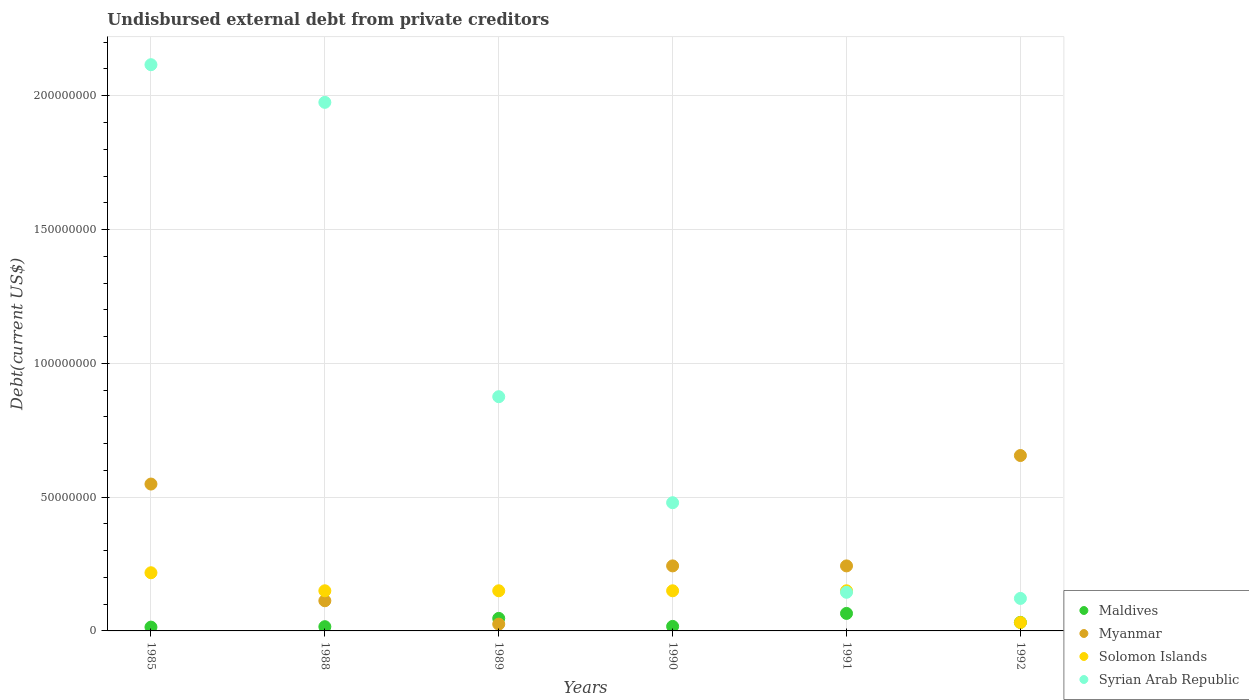How many different coloured dotlines are there?
Your answer should be very brief. 4. What is the total debt in Myanmar in 1990?
Provide a succinct answer. 2.43e+07. Across all years, what is the maximum total debt in Maldives?
Keep it short and to the point. 6.54e+06. Across all years, what is the minimum total debt in Syrian Arab Republic?
Keep it short and to the point. 1.21e+07. What is the total total debt in Syrian Arab Republic in the graph?
Make the answer very short. 5.71e+08. What is the difference between the total debt in Myanmar in 1985 and that in 1991?
Ensure brevity in your answer.  3.06e+07. What is the difference between the total debt in Myanmar in 1985 and the total debt in Syrian Arab Republic in 1988?
Keep it short and to the point. -1.43e+08. What is the average total debt in Syrian Arab Republic per year?
Provide a short and direct response. 9.52e+07. In the year 1988, what is the difference between the total debt in Maldives and total debt in Solomon Islands?
Offer a very short reply. -1.34e+07. What is the ratio of the total debt in Syrian Arab Republic in 1988 to that in 1990?
Your answer should be very brief. 4.12. Is the total debt in Myanmar in 1989 less than that in 1990?
Your answer should be very brief. Yes. Is the difference between the total debt in Maldives in 1988 and 1991 greater than the difference between the total debt in Solomon Islands in 1988 and 1991?
Make the answer very short. No. What is the difference between the highest and the second highest total debt in Myanmar?
Offer a very short reply. 1.07e+07. What is the difference between the highest and the lowest total debt in Myanmar?
Your response must be concise. 6.30e+07. Is the sum of the total debt in Syrian Arab Republic in 1985 and 1991 greater than the maximum total debt in Solomon Islands across all years?
Keep it short and to the point. Yes. Is it the case that in every year, the sum of the total debt in Myanmar and total debt in Maldives  is greater than the sum of total debt in Solomon Islands and total debt in Syrian Arab Republic?
Provide a short and direct response. No. Is the total debt in Myanmar strictly less than the total debt in Maldives over the years?
Ensure brevity in your answer.  No. How many dotlines are there?
Your answer should be compact. 4. How many years are there in the graph?
Your answer should be compact. 6. What is the difference between two consecutive major ticks on the Y-axis?
Offer a very short reply. 5.00e+07. Are the values on the major ticks of Y-axis written in scientific E-notation?
Ensure brevity in your answer.  No. Does the graph contain grids?
Make the answer very short. Yes. How many legend labels are there?
Give a very brief answer. 4. What is the title of the graph?
Give a very brief answer. Undisbursed external debt from private creditors. Does "Egypt, Arab Rep." appear as one of the legend labels in the graph?
Provide a short and direct response. No. What is the label or title of the X-axis?
Ensure brevity in your answer.  Years. What is the label or title of the Y-axis?
Your response must be concise. Debt(current US$). What is the Debt(current US$) in Maldives in 1985?
Your response must be concise. 1.42e+06. What is the Debt(current US$) in Myanmar in 1985?
Ensure brevity in your answer.  5.49e+07. What is the Debt(current US$) in Solomon Islands in 1985?
Provide a succinct answer. 2.17e+07. What is the Debt(current US$) in Syrian Arab Republic in 1985?
Offer a very short reply. 2.12e+08. What is the Debt(current US$) of Maldives in 1988?
Make the answer very short. 1.58e+06. What is the Debt(current US$) in Myanmar in 1988?
Offer a terse response. 1.13e+07. What is the Debt(current US$) in Solomon Islands in 1988?
Offer a very short reply. 1.50e+07. What is the Debt(current US$) of Syrian Arab Republic in 1988?
Your answer should be compact. 1.98e+08. What is the Debt(current US$) in Maldives in 1989?
Keep it short and to the point. 4.68e+06. What is the Debt(current US$) in Myanmar in 1989?
Ensure brevity in your answer.  2.54e+06. What is the Debt(current US$) of Solomon Islands in 1989?
Ensure brevity in your answer.  1.50e+07. What is the Debt(current US$) in Syrian Arab Republic in 1989?
Make the answer very short. 8.75e+07. What is the Debt(current US$) of Maldives in 1990?
Keep it short and to the point. 1.69e+06. What is the Debt(current US$) of Myanmar in 1990?
Your response must be concise. 2.43e+07. What is the Debt(current US$) in Solomon Islands in 1990?
Your response must be concise. 1.50e+07. What is the Debt(current US$) in Syrian Arab Republic in 1990?
Offer a very short reply. 4.79e+07. What is the Debt(current US$) in Maldives in 1991?
Keep it short and to the point. 6.54e+06. What is the Debt(current US$) of Myanmar in 1991?
Offer a very short reply. 2.43e+07. What is the Debt(current US$) in Solomon Islands in 1991?
Provide a succinct answer. 1.50e+07. What is the Debt(current US$) in Syrian Arab Republic in 1991?
Your answer should be compact. 1.44e+07. What is the Debt(current US$) of Maldives in 1992?
Provide a succinct answer. 3.19e+06. What is the Debt(current US$) of Myanmar in 1992?
Offer a terse response. 6.56e+07. What is the Debt(current US$) of Solomon Islands in 1992?
Your response must be concise. 3.13e+06. What is the Debt(current US$) of Syrian Arab Republic in 1992?
Ensure brevity in your answer.  1.21e+07. Across all years, what is the maximum Debt(current US$) in Maldives?
Your answer should be compact. 6.54e+06. Across all years, what is the maximum Debt(current US$) in Myanmar?
Your answer should be very brief. 6.56e+07. Across all years, what is the maximum Debt(current US$) in Solomon Islands?
Ensure brevity in your answer.  2.17e+07. Across all years, what is the maximum Debt(current US$) in Syrian Arab Republic?
Keep it short and to the point. 2.12e+08. Across all years, what is the minimum Debt(current US$) in Maldives?
Your answer should be very brief. 1.42e+06. Across all years, what is the minimum Debt(current US$) in Myanmar?
Your response must be concise. 2.54e+06. Across all years, what is the minimum Debt(current US$) of Solomon Islands?
Offer a very short reply. 3.13e+06. Across all years, what is the minimum Debt(current US$) in Syrian Arab Republic?
Ensure brevity in your answer.  1.21e+07. What is the total Debt(current US$) in Maldives in the graph?
Your answer should be very brief. 1.91e+07. What is the total Debt(current US$) of Myanmar in the graph?
Keep it short and to the point. 1.83e+08. What is the total Debt(current US$) of Solomon Islands in the graph?
Offer a terse response. 8.49e+07. What is the total Debt(current US$) in Syrian Arab Republic in the graph?
Keep it short and to the point. 5.71e+08. What is the difference between the Debt(current US$) in Maldives in 1985 and that in 1988?
Offer a very short reply. -1.66e+05. What is the difference between the Debt(current US$) of Myanmar in 1985 and that in 1988?
Your answer should be very brief. 4.36e+07. What is the difference between the Debt(current US$) of Solomon Islands in 1985 and that in 1988?
Give a very brief answer. 6.74e+06. What is the difference between the Debt(current US$) in Syrian Arab Republic in 1985 and that in 1988?
Ensure brevity in your answer.  1.41e+07. What is the difference between the Debt(current US$) in Maldives in 1985 and that in 1989?
Offer a terse response. -3.26e+06. What is the difference between the Debt(current US$) in Myanmar in 1985 and that in 1989?
Ensure brevity in your answer.  5.23e+07. What is the difference between the Debt(current US$) in Solomon Islands in 1985 and that in 1989?
Provide a short and direct response. 6.74e+06. What is the difference between the Debt(current US$) of Syrian Arab Republic in 1985 and that in 1989?
Provide a short and direct response. 1.24e+08. What is the difference between the Debt(current US$) in Maldives in 1985 and that in 1990?
Keep it short and to the point. -2.70e+05. What is the difference between the Debt(current US$) in Myanmar in 1985 and that in 1990?
Provide a short and direct response. 3.06e+07. What is the difference between the Debt(current US$) of Solomon Islands in 1985 and that in 1990?
Offer a terse response. 6.74e+06. What is the difference between the Debt(current US$) of Syrian Arab Republic in 1985 and that in 1990?
Offer a very short reply. 1.64e+08. What is the difference between the Debt(current US$) in Maldives in 1985 and that in 1991?
Your response must be concise. -5.12e+06. What is the difference between the Debt(current US$) in Myanmar in 1985 and that in 1991?
Make the answer very short. 3.06e+07. What is the difference between the Debt(current US$) in Solomon Islands in 1985 and that in 1991?
Offer a very short reply. 6.74e+06. What is the difference between the Debt(current US$) of Syrian Arab Republic in 1985 and that in 1991?
Your answer should be very brief. 1.97e+08. What is the difference between the Debt(current US$) in Maldives in 1985 and that in 1992?
Keep it short and to the point. -1.77e+06. What is the difference between the Debt(current US$) of Myanmar in 1985 and that in 1992?
Give a very brief answer. -1.07e+07. What is the difference between the Debt(current US$) of Solomon Islands in 1985 and that in 1992?
Keep it short and to the point. 1.86e+07. What is the difference between the Debt(current US$) in Syrian Arab Republic in 1985 and that in 1992?
Offer a very short reply. 1.99e+08. What is the difference between the Debt(current US$) in Maldives in 1988 and that in 1989?
Offer a very short reply. -3.10e+06. What is the difference between the Debt(current US$) in Myanmar in 1988 and that in 1989?
Your answer should be compact. 8.74e+06. What is the difference between the Debt(current US$) in Syrian Arab Republic in 1988 and that in 1989?
Make the answer very short. 1.10e+08. What is the difference between the Debt(current US$) of Maldives in 1988 and that in 1990?
Give a very brief answer. -1.04e+05. What is the difference between the Debt(current US$) of Myanmar in 1988 and that in 1990?
Give a very brief answer. -1.30e+07. What is the difference between the Debt(current US$) in Solomon Islands in 1988 and that in 1990?
Your response must be concise. 0. What is the difference between the Debt(current US$) in Syrian Arab Republic in 1988 and that in 1990?
Offer a terse response. 1.50e+08. What is the difference between the Debt(current US$) of Maldives in 1988 and that in 1991?
Offer a very short reply. -4.96e+06. What is the difference between the Debt(current US$) of Myanmar in 1988 and that in 1991?
Your answer should be very brief. -1.30e+07. What is the difference between the Debt(current US$) in Syrian Arab Republic in 1988 and that in 1991?
Offer a terse response. 1.83e+08. What is the difference between the Debt(current US$) in Maldives in 1988 and that in 1992?
Your answer should be compact. -1.60e+06. What is the difference between the Debt(current US$) of Myanmar in 1988 and that in 1992?
Provide a succinct answer. -5.43e+07. What is the difference between the Debt(current US$) of Solomon Islands in 1988 and that in 1992?
Give a very brief answer. 1.19e+07. What is the difference between the Debt(current US$) in Syrian Arab Republic in 1988 and that in 1992?
Offer a terse response. 1.85e+08. What is the difference between the Debt(current US$) in Maldives in 1989 and that in 1990?
Offer a terse response. 3.00e+06. What is the difference between the Debt(current US$) of Myanmar in 1989 and that in 1990?
Your response must be concise. -2.18e+07. What is the difference between the Debt(current US$) in Syrian Arab Republic in 1989 and that in 1990?
Keep it short and to the point. 3.96e+07. What is the difference between the Debt(current US$) of Maldives in 1989 and that in 1991?
Provide a succinct answer. -1.86e+06. What is the difference between the Debt(current US$) in Myanmar in 1989 and that in 1991?
Ensure brevity in your answer.  -2.18e+07. What is the difference between the Debt(current US$) of Syrian Arab Republic in 1989 and that in 1991?
Your answer should be compact. 7.31e+07. What is the difference between the Debt(current US$) in Maldives in 1989 and that in 1992?
Your answer should be compact. 1.50e+06. What is the difference between the Debt(current US$) in Myanmar in 1989 and that in 1992?
Provide a succinct answer. -6.30e+07. What is the difference between the Debt(current US$) of Solomon Islands in 1989 and that in 1992?
Keep it short and to the point. 1.19e+07. What is the difference between the Debt(current US$) in Syrian Arab Republic in 1989 and that in 1992?
Keep it short and to the point. 7.54e+07. What is the difference between the Debt(current US$) of Maldives in 1990 and that in 1991?
Provide a short and direct response. -4.85e+06. What is the difference between the Debt(current US$) of Myanmar in 1990 and that in 1991?
Provide a short and direct response. 0. What is the difference between the Debt(current US$) in Solomon Islands in 1990 and that in 1991?
Offer a very short reply. 0. What is the difference between the Debt(current US$) of Syrian Arab Republic in 1990 and that in 1991?
Provide a short and direct response. 3.35e+07. What is the difference between the Debt(current US$) of Maldives in 1990 and that in 1992?
Your response must be concise. -1.50e+06. What is the difference between the Debt(current US$) of Myanmar in 1990 and that in 1992?
Provide a succinct answer. -4.12e+07. What is the difference between the Debt(current US$) in Solomon Islands in 1990 and that in 1992?
Offer a terse response. 1.19e+07. What is the difference between the Debt(current US$) in Syrian Arab Republic in 1990 and that in 1992?
Provide a short and direct response. 3.58e+07. What is the difference between the Debt(current US$) in Maldives in 1991 and that in 1992?
Ensure brevity in your answer.  3.35e+06. What is the difference between the Debt(current US$) of Myanmar in 1991 and that in 1992?
Provide a short and direct response. -4.12e+07. What is the difference between the Debt(current US$) in Solomon Islands in 1991 and that in 1992?
Provide a short and direct response. 1.19e+07. What is the difference between the Debt(current US$) of Syrian Arab Republic in 1991 and that in 1992?
Give a very brief answer. 2.29e+06. What is the difference between the Debt(current US$) of Maldives in 1985 and the Debt(current US$) of Myanmar in 1988?
Give a very brief answer. -9.86e+06. What is the difference between the Debt(current US$) in Maldives in 1985 and the Debt(current US$) in Solomon Islands in 1988?
Provide a short and direct response. -1.36e+07. What is the difference between the Debt(current US$) in Maldives in 1985 and the Debt(current US$) in Syrian Arab Republic in 1988?
Provide a succinct answer. -1.96e+08. What is the difference between the Debt(current US$) in Myanmar in 1985 and the Debt(current US$) in Solomon Islands in 1988?
Your response must be concise. 3.99e+07. What is the difference between the Debt(current US$) in Myanmar in 1985 and the Debt(current US$) in Syrian Arab Republic in 1988?
Offer a terse response. -1.43e+08. What is the difference between the Debt(current US$) of Solomon Islands in 1985 and the Debt(current US$) of Syrian Arab Republic in 1988?
Your response must be concise. -1.76e+08. What is the difference between the Debt(current US$) of Maldives in 1985 and the Debt(current US$) of Myanmar in 1989?
Offer a terse response. -1.12e+06. What is the difference between the Debt(current US$) in Maldives in 1985 and the Debt(current US$) in Solomon Islands in 1989?
Make the answer very short. -1.36e+07. What is the difference between the Debt(current US$) in Maldives in 1985 and the Debt(current US$) in Syrian Arab Republic in 1989?
Provide a short and direct response. -8.61e+07. What is the difference between the Debt(current US$) of Myanmar in 1985 and the Debt(current US$) of Solomon Islands in 1989?
Your answer should be compact. 3.99e+07. What is the difference between the Debt(current US$) of Myanmar in 1985 and the Debt(current US$) of Syrian Arab Republic in 1989?
Make the answer very short. -3.26e+07. What is the difference between the Debt(current US$) of Solomon Islands in 1985 and the Debt(current US$) of Syrian Arab Republic in 1989?
Provide a succinct answer. -6.58e+07. What is the difference between the Debt(current US$) in Maldives in 1985 and the Debt(current US$) in Myanmar in 1990?
Your response must be concise. -2.29e+07. What is the difference between the Debt(current US$) in Maldives in 1985 and the Debt(current US$) in Solomon Islands in 1990?
Provide a succinct answer. -1.36e+07. What is the difference between the Debt(current US$) in Maldives in 1985 and the Debt(current US$) in Syrian Arab Republic in 1990?
Your answer should be compact. -4.65e+07. What is the difference between the Debt(current US$) in Myanmar in 1985 and the Debt(current US$) in Solomon Islands in 1990?
Make the answer very short. 3.99e+07. What is the difference between the Debt(current US$) in Myanmar in 1985 and the Debt(current US$) in Syrian Arab Republic in 1990?
Your answer should be very brief. 6.97e+06. What is the difference between the Debt(current US$) of Solomon Islands in 1985 and the Debt(current US$) of Syrian Arab Republic in 1990?
Make the answer very short. -2.62e+07. What is the difference between the Debt(current US$) of Maldives in 1985 and the Debt(current US$) of Myanmar in 1991?
Provide a succinct answer. -2.29e+07. What is the difference between the Debt(current US$) of Maldives in 1985 and the Debt(current US$) of Solomon Islands in 1991?
Offer a very short reply. -1.36e+07. What is the difference between the Debt(current US$) in Maldives in 1985 and the Debt(current US$) in Syrian Arab Republic in 1991?
Provide a short and direct response. -1.30e+07. What is the difference between the Debt(current US$) in Myanmar in 1985 and the Debt(current US$) in Solomon Islands in 1991?
Ensure brevity in your answer.  3.99e+07. What is the difference between the Debt(current US$) in Myanmar in 1985 and the Debt(current US$) in Syrian Arab Republic in 1991?
Provide a succinct answer. 4.04e+07. What is the difference between the Debt(current US$) in Solomon Islands in 1985 and the Debt(current US$) in Syrian Arab Republic in 1991?
Offer a terse response. 7.30e+06. What is the difference between the Debt(current US$) of Maldives in 1985 and the Debt(current US$) of Myanmar in 1992?
Keep it short and to the point. -6.41e+07. What is the difference between the Debt(current US$) of Maldives in 1985 and the Debt(current US$) of Solomon Islands in 1992?
Give a very brief answer. -1.72e+06. What is the difference between the Debt(current US$) of Maldives in 1985 and the Debt(current US$) of Syrian Arab Republic in 1992?
Offer a terse response. -1.07e+07. What is the difference between the Debt(current US$) of Myanmar in 1985 and the Debt(current US$) of Solomon Islands in 1992?
Your answer should be very brief. 5.18e+07. What is the difference between the Debt(current US$) in Myanmar in 1985 and the Debt(current US$) in Syrian Arab Republic in 1992?
Provide a succinct answer. 4.27e+07. What is the difference between the Debt(current US$) of Solomon Islands in 1985 and the Debt(current US$) of Syrian Arab Republic in 1992?
Provide a short and direct response. 9.59e+06. What is the difference between the Debt(current US$) of Maldives in 1988 and the Debt(current US$) of Myanmar in 1989?
Give a very brief answer. -9.54e+05. What is the difference between the Debt(current US$) in Maldives in 1988 and the Debt(current US$) in Solomon Islands in 1989?
Your answer should be very brief. -1.34e+07. What is the difference between the Debt(current US$) of Maldives in 1988 and the Debt(current US$) of Syrian Arab Republic in 1989?
Your answer should be very brief. -8.59e+07. What is the difference between the Debt(current US$) in Myanmar in 1988 and the Debt(current US$) in Solomon Islands in 1989?
Offer a terse response. -3.72e+06. What is the difference between the Debt(current US$) in Myanmar in 1988 and the Debt(current US$) in Syrian Arab Republic in 1989?
Your response must be concise. -7.63e+07. What is the difference between the Debt(current US$) in Solomon Islands in 1988 and the Debt(current US$) in Syrian Arab Republic in 1989?
Your answer should be very brief. -7.25e+07. What is the difference between the Debt(current US$) in Maldives in 1988 and the Debt(current US$) in Myanmar in 1990?
Offer a terse response. -2.27e+07. What is the difference between the Debt(current US$) in Maldives in 1988 and the Debt(current US$) in Solomon Islands in 1990?
Give a very brief answer. -1.34e+07. What is the difference between the Debt(current US$) in Maldives in 1988 and the Debt(current US$) in Syrian Arab Republic in 1990?
Give a very brief answer. -4.63e+07. What is the difference between the Debt(current US$) in Myanmar in 1988 and the Debt(current US$) in Solomon Islands in 1990?
Give a very brief answer. -3.72e+06. What is the difference between the Debt(current US$) of Myanmar in 1988 and the Debt(current US$) of Syrian Arab Republic in 1990?
Keep it short and to the point. -3.66e+07. What is the difference between the Debt(current US$) of Solomon Islands in 1988 and the Debt(current US$) of Syrian Arab Republic in 1990?
Provide a succinct answer. -3.29e+07. What is the difference between the Debt(current US$) of Maldives in 1988 and the Debt(current US$) of Myanmar in 1991?
Offer a very short reply. -2.27e+07. What is the difference between the Debt(current US$) in Maldives in 1988 and the Debt(current US$) in Solomon Islands in 1991?
Ensure brevity in your answer.  -1.34e+07. What is the difference between the Debt(current US$) in Maldives in 1988 and the Debt(current US$) in Syrian Arab Republic in 1991?
Make the answer very short. -1.28e+07. What is the difference between the Debt(current US$) in Myanmar in 1988 and the Debt(current US$) in Solomon Islands in 1991?
Your answer should be compact. -3.72e+06. What is the difference between the Debt(current US$) in Myanmar in 1988 and the Debt(current US$) in Syrian Arab Republic in 1991?
Your response must be concise. -3.16e+06. What is the difference between the Debt(current US$) in Solomon Islands in 1988 and the Debt(current US$) in Syrian Arab Republic in 1991?
Your response must be concise. 5.65e+05. What is the difference between the Debt(current US$) of Maldives in 1988 and the Debt(current US$) of Myanmar in 1992?
Provide a succinct answer. -6.40e+07. What is the difference between the Debt(current US$) of Maldives in 1988 and the Debt(current US$) of Solomon Islands in 1992?
Provide a short and direct response. -1.55e+06. What is the difference between the Debt(current US$) in Maldives in 1988 and the Debt(current US$) in Syrian Arab Republic in 1992?
Offer a terse response. -1.06e+07. What is the difference between the Debt(current US$) in Myanmar in 1988 and the Debt(current US$) in Solomon Islands in 1992?
Your answer should be very brief. 8.14e+06. What is the difference between the Debt(current US$) in Myanmar in 1988 and the Debt(current US$) in Syrian Arab Republic in 1992?
Your response must be concise. -8.70e+05. What is the difference between the Debt(current US$) of Solomon Islands in 1988 and the Debt(current US$) of Syrian Arab Republic in 1992?
Your answer should be very brief. 2.85e+06. What is the difference between the Debt(current US$) in Maldives in 1989 and the Debt(current US$) in Myanmar in 1990?
Offer a very short reply. -1.96e+07. What is the difference between the Debt(current US$) in Maldives in 1989 and the Debt(current US$) in Solomon Islands in 1990?
Ensure brevity in your answer.  -1.03e+07. What is the difference between the Debt(current US$) in Maldives in 1989 and the Debt(current US$) in Syrian Arab Republic in 1990?
Keep it short and to the point. -4.32e+07. What is the difference between the Debt(current US$) of Myanmar in 1989 and the Debt(current US$) of Solomon Islands in 1990?
Your response must be concise. -1.25e+07. What is the difference between the Debt(current US$) in Myanmar in 1989 and the Debt(current US$) in Syrian Arab Republic in 1990?
Keep it short and to the point. -4.54e+07. What is the difference between the Debt(current US$) of Solomon Islands in 1989 and the Debt(current US$) of Syrian Arab Republic in 1990?
Offer a very short reply. -3.29e+07. What is the difference between the Debt(current US$) in Maldives in 1989 and the Debt(current US$) in Myanmar in 1991?
Offer a terse response. -1.96e+07. What is the difference between the Debt(current US$) of Maldives in 1989 and the Debt(current US$) of Solomon Islands in 1991?
Offer a terse response. -1.03e+07. What is the difference between the Debt(current US$) in Maldives in 1989 and the Debt(current US$) in Syrian Arab Republic in 1991?
Give a very brief answer. -9.75e+06. What is the difference between the Debt(current US$) in Myanmar in 1989 and the Debt(current US$) in Solomon Islands in 1991?
Your answer should be very brief. -1.25e+07. What is the difference between the Debt(current US$) in Myanmar in 1989 and the Debt(current US$) in Syrian Arab Republic in 1991?
Your answer should be very brief. -1.19e+07. What is the difference between the Debt(current US$) of Solomon Islands in 1989 and the Debt(current US$) of Syrian Arab Republic in 1991?
Make the answer very short. 5.65e+05. What is the difference between the Debt(current US$) in Maldives in 1989 and the Debt(current US$) in Myanmar in 1992?
Provide a succinct answer. -6.09e+07. What is the difference between the Debt(current US$) of Maldives in 1989 and the Debt(current US$) of Solomon Islands in 1992?
Your answer should be compact. 1.55e+06. What is the difference between the Debt(current US$) in Maldives in 1989 and the Debt(current US$) in Syrian Arab Republic in 1992?
Your answer should be compact. -7.46e+06. What is the difference between the Debt(current US$) of Myanmar in 1989 and the Debt(current US$) of Solomon Islands in 1992?
Your answer should be compact. -5.95e+05. What is the difference between the Debt(current US$) of Myanmar in 1989 and the Debt(current US$) of Syrian Arab Republic in 1992?
Your answer should be compact. -9.61e+06. What is the difference between the Debt(current US$) in Solomon Islands in 1989 and the Debt(current US$) in Syrian Arab Republic in 1992?
Your response must be concise. 2.85e+06. What is the difference between the Debt(current US$) of Maldives in 1990 and the Debt(current US$) of Myanmar in 1991?
Your answer should be compact. -2.26e+07. What is the difference between the Debt(current US$) in Maldives in 1990 and the Debt(current US$) in Solomon Islands in 1991?
Your response must be concise. -1.33e+07. What is the difference between the Debt(current US$) of Maldives in 1990 and the Debt(current US$) of Syrian Arab Republic in 1991?
Offer a very short reply. -1.27e+07. What is the difference between the Debt(current US$) in Myanmar in 1990 and the Debt(current US$) in Solomon Islands in 1991?
Offer a terse response. 9.30e+06. What is the difference between the Debt(current US$) in Myanmar in 1990 and the Debt(current US$) in Syrian Arab Republic in 1991?
Your response must be concise. 9.86e+06. What is the difference between the Debt(current US$) in Solomon Islands in 1990 and the Debt(current US$) in Syrian Arab Republic in 1991?
Offer a very short reply. 5.65e+05. What is the difference between the Debt(current US$) of Maldives in 1990 and the Debt(current US$) of Myanmar in 1992?
Provide a short and direct response. -6.39e+07. What is the difference between the Debt(current US$) in Maldives in 1990 and the Debt(current US$) in Solomon Islands in 1992?
Your answer should be compact. -1.44e+06. What is the difference between the Debt(current US$) of Maldives in 1990 and the Debt(current US$) of Syrian Arab Republic in 1992?
Provide a short and direct response. -1.05e+07. What is the difference between the Debt(current US$) in Myanmar in 1990 and the Debt(current US$) in Solomon Islands in 1992?
Provide a succinct answer. 2.12e+07. What is the difference between the Debt(current US$) of Myanmar in 1990 and the Debt(current US$) of Syrian Arab Republic in 1992?
Keep it short and to the point. 1.22e+07. What is the difference between the Debt(current US$) of Solomon Islands in 1990 and the Debt(current US$) of Syrian Arab Republic in 1992?
Give a very brief answer. 2.85e+06. What is the difference between the Debt(current US$) of Maldives in 1991 and the Debt(current US$) of Myanmar in 1992?
Offer a very short reply. -5.90e+07. What is the difference between the Debt(current US$) of Maldives in 1991 and the Debt(current US$) of Solomon Islands in 1992?
Your answer should be very brief. 3.41e+06. What is the difference between the Debt(current US$) in Maldives in 1991 and the Debt(current US$) in Syrian Arab Republic in 1992?
Keep it short and to the point. -5.60e+06. What is the difference between the Debt(current US$) of Myanmar in 1991 and the Debt(current US$) of Solomon Islands in 1992?
Your answer should be very brief. 2.12e+07. What is the difference between the Debt(current US$) in Myanmar in 1991 and the Debt(current US$) in Syrian Arab Republic in 1992?
Make the answer very short. 1.22e+07. What is the difference between the Debt(current US$) in Solomon Islands in 1991 and the Debt(current US$) in Syrian Arab Republic in 1992?
Your answer should be compact. 2.85e+06. What is the average Debt(current US$) in Maldives per year?
Your answer should be very brief. 3.18e+06. What is the average Debt(current US$) in Myanmar per year?
Offer a terse response. 3.05e+07. What is the average Debt(current US$) in Solomon Islands per year?
Give a very brief answer. 1.41e+07. What is the average Debt(current US$) in Syrian Arab Republic per year?
Provide a succinct answer. 9.52e+07. In the year 1985, what is the difference between the Debt(current US$) in Maldives and Debt(current US$) in Myanmar?
Make the answer very short. -5.35e+07. In the year 1985, what is the difference between the Debt(current US$) of Maldives and Debt(current US$) of Solomon Islands?
Give a very brief answer. -2.03e+07. In the year 1985, what is the difference between the Debt(current US$) in Maldives and Debt(current US$) in Syrian Arab Republic?
Make the answer very short. -2.10e+08. In the year 1985, what is the difference between the Debt(current US$) in Myanmar and Debt(current US$) in Solomon Islands?
Give a very brief answer. 3.31e+07. In the year 1985, what is the difference between the Debt(current US$) of Myanmar and Debt(current US$) of Syrian Arab Republic?
Give a very brief answer. -1.57e+08. In the year 1985, what is the difference between the Debt(current US$) of Solomon Islands and Debt(current US$) of Syrian Arab Republic?
Offer a terse response. -1.90e+08. In the year 1988, what is the difference between the Debt(current US$) of Maldives and Debt(current US$) of Myanmar?
Ensure brevity in your answer.  -9.69e+06. In the year 1988, what is the difference between the Debt(current US$) of Maldives and Debt(current US$) of Solomon Islands?
Keep it short and to the point. -1.34e+07. In the year 1988, what is the difference between the Debt(current US$) of Maldives and Debt(current US$) of Syrian Arab Republic?
Your answer should be very brief. -1.96e+08. In the year 1988, what is the difference between the Debt(current US$) in Myanmar and Debt(current US$) in Solomon Islands?
Give a very brief answer. -3.72e+06. In the year 1988, what is the difference between the Debt(current US$) in Myanmar and Debt(current US$) in Syrian Arab Republic?
Your response must be concise. -1.86e+08. In the year 1988, what is the difference between the Debt(current US$) in Solomon Islands and Debt(current US$) in Syrian Arab Republic?
Give a very brief answer. -1.83e+08. In the year 1989, what is the difference between the Debt(current US$) in Maldives and Debt(current US$) in Myanmar?
Your response must be concise. 2.14e+06. In the year 1989, what is the difference between the Debt(current US$) of Maldives and Debt(current US$) of Solomon Islands?
Provide a short and direct response. -1.03e+07. In the year 1989, what is the difference between the Debt(current US$) in Maldives and Debt(current US$) in Syrian Arab Republic?
Give a very brief answer. -8.28e+07. In the year 1989, what is the difference between the Debt(current US$) in Myanmar and Debt(current US$) in Solomon Islands?
Your response must be concise. -1.25e+07. In the year 1989, what is the difference between the Debt(current US$) in Myanmar and Debt(current US$) in Syrian Arab Republic?
Your answer should be compact. -8.50e+07. In the year 1989, what is the difference between the Debt(current US$) of Solomon Islands and Debt(current US$) of Syrian Arab Republic?
Offer a terse response. -7.25e+07. In the year 1990, what is the difference between the Debt(current US$) in Maldives and Debt(current US$) in Myanmar?
Ensure brevity in your answer.  -2.26e+07. In the year 1990, what is the difference between the Debt(current US$) of Maldives and Debt(current US$) of Solomon Islands?
Make the answer very short. -1.33e+07. In the year 1990, what is the difference between the Debt(current US$) of Maldives and Debt(current US$) of Syrian Arab Republic?
Your response must be concise. -4.62e+07. In the year 1990, what is the difference between the Debt(current US$) in Myanmar and Debt(current US$) in Solomon Islands?
Your response must be concise. 9.30e+06. In the year 1990, what is the difference between the Debt(current US$) in Myanmar and Debt(current US$) in Syrian Arab Republic?
Your answer should be very brief. -2.36e+07. In the year 1990, what is the difference between the Debt(current US$) of Solomon Islands and Debt(current US$) of Syrian Arab Republic?
Your answer should be very brief. -3.29e+07. In the year 1991, what is the difference between the Debt(current US$) of Maldives and Debt(current US$) of Myanmar?
Offer a very short reply. -1.78e+07. In the year 1991, what is the difference between the Debt(current US$) of Maldives and Debt(current US$) of Solomon Islands?
Offer a terse response. -8.46e+06. In the year 1991, what is the difference between the Debt(current US$) in Maldives and Debt(current US$) in Syrian Arab Republic?
Provide a short and direct response. -7.89e+06. In the year 1991, what is the difference between the Debt(current US$) of Myanmar and Debt(current US$) of Solomon Islands?
Your answer should be very brief. 9.30e+06. In the year 1991, what is the difference between the Debt(current US$) in Myanmar and Debt(current US$) in Syrian Arab Republic?
Provide a short and direct response. 9.86e+06. In the year 1991, what is the difference between the Debt(current US$) in Solomon Islands and Debt(current US$) in Syrian Arab Republic?
Keep it short and to the point. 5.65e+05. In the year 1992, what is the difference between the Debt(current US$) of Maldives and Debt(current US$) of Myanmar?
Provide a short and direct response. -6.24e+07. In the year 1992, what is the difference between the Debt(current US$) of Maldives and Debt(current US$) of Solomon Islands?
Your response must be concise. 5.50e+04. In the year 1992, what is the difference between the Debt(current US$) of Maldives and Debt(current US$) of Syrian Arab Republic?
Ensure brevity in your answer.  -8.96e+06. In the year 1992, what is the difference between the Debt(current US$) of Myanmar and Debt(current US$) of Solomon Islands?
Provide a short and direct response. 6.24e+07. In the year 1992, what is the difference between the Debt(current US$) of Myanmar and Debt(current US$) of Syrian Arab Republic?
Make the answer very short. 5.34e+07. In the year 1992, what is the difference between the Debt(current US$) in Solomon Islands and Debt(current US$) in Syrian Arab Republic?
Give a very brief answer. -9.01e+06. What is the ratio of the Debt(current US$) in Maldives in 1985 to that in 1988?
Provide a short and direct response. 0.9. What is the ratio of the Debt(current US$) in Myanmar in 1985 to that in 1988?
Make the answer very short. 4.87. What is the ratio of the Debt(current US$) of Solomon Islands in 1985 to that in 1988?
Offer a terse response. 1.45. What is the ratio of the Debt(current US$) in Syrian Arab Republic in 1985 to that in 1988?
Offer a terse response. 1.07. What is the ratio of the Debt(current US$) of Maldives in 1985 to that in 1989?
Your answer should be very brief. 0.3. What is the ratio of the Debt(current US$) of Myanmar in 1985 to that in 1989?
Make the answer very short. 21.62. What is the ratio of the Debt(current US$) of Solomon Islands in 1985 to that in 1989?
Make the answer very short. 1.45. What is the ratio of the Debt(current US$) in Syrian Arab Republic in 1985 to that in 1989?
Make the answer very short. 2.42. What is the ratio of the Debt(current US$) in Maldives in 1985 to that in 1990?
Your answer should be compact. 0.84. What is the ratio of the Debt(current US$) of Myanmar in 1985 to that in 1990?
Make the answer very short. 2.26. What is the ratio of the Debt(current US$) in Solomon Islands in 1985 to that in 1990?
Provide a succinct answer. 1.45. What is the ratio of the Debt(current US$) of Syrian Arab Republic in 1985 to that in 1990?
Ensure brevity in your answer.  4.42. What is the ratio of the Debt(current US$) of Maldives in 1985 to that in 1991?
Ensure brevity in your answer.  0.22. What is the ratio of the Debt(current US$) in Myanmar in 1985 to that in 1991?
Provide a short and direct response. 2.26. What is the ratio of the Debt(current US$) of Solomon Islands in 1985 to that in 1991?
Make the answer very short. 1.45. What is the ratio of the Debt(current US$) of Syrian Arab Republic in 1985 to that in 1991?
Your answer should be compact. 14.66. What is the ratio of the Debt(current US$) in Maldives in 1985 to that in 1992?
Your response must be concise. 0.45. What is the ratio of the Debt(current US$) in Myanmar in 1985 to that in 1992?
Keep it short and to the point. 0.84. What is the ratio of the Debt(current US$) of Solomon Islands in 1985 to that in 1992?
Your response must be concise. 6.94. What is the ratio of the Debt(current US$) in Syrian Arab Republic in 1985 to that in 1992?
Offer a terse response. 17.42. What is the ratio of the Debt(current US$) in Maldives in 1988 to that in 1989?
Provide a succinct answer. 0.34. What is the ratio of the Debt(current US$) in Myanmar in 1988 to that in 1989?
Give a very brief answer. 4.44. What is the ratio of the Debt(current US$) of Syrian Arab Republic in 1988 to that in 1989?
Ensure brevity in your answer.  2.26. What is the ratio of the Debt(current US$) in Maldives in 1988 to that in 1990?
Give a very brief answer. 0.94. What is the ratio of the Debt(current US$) in Myanmar in 1988 to that in 1990?
Your response must be concise. 0.46. What is the ratio of the Debt(current US$) of Syrian Arab Republic in 1988 to that in 1990?
Give a very brief answer. 4.12. What is the ratio of the Debt(current US$) of Maldives in 1988 to that in 1991?
Give a very brief answer. 0.24. What is the ratio of the Debt(current US$) in Myanmar in 1988 to that in 1991?
Ensure brevity in your answer.  0.46. What is the ratio of the Debt(current US$) in Syrian Arab Republic in 1988 to that in 1991?
Offer a very short reply. 13.68. What is the ratio of the Debt(current US$) in Maldives in 1988 to that in 1992?
Give a very brief answer. 0.5. What is the ratio of the Debt(current US$) of Myanmar in 1988 to that in 1992?
Give a very brief answer. 0.17. What is the ratio of the Debt(current US$) in Solomon Islands in 1988 to that in 1992?
Provide a short and direct response. 4.79. What is the ratio of the Debt(current US$) of Syrian Arab Republic in 1988 to that in 1992?
Ensure brevity in your answer.  16.26. What is the ratio of the Debt(current US$) of Maldives in 1989 to that in 1990?
Your response must be concise. 2.77. What is the ratio of the Debt(current US$) in Myanmar in 1989 to that in 1990?
Offer a very short reply. 0.1. What is the ratio of the Debt(current US$) of Syrian Arab Republic in 1989 to that in 1990?
Make the answer very short. 1.83. What is the ratio of the Debt(current US$) in Maldives in 1989 to that in 1991?
Provide a succinct answer. 0.72. What is the ratio of the Debt(current US$) of Myanmar in 1989 to that in 1991?
Provide a short and direct response. 0.1. What is the ratio of the Debt(current US$) in Solomon Islands in 1989 to that in 1991?
Your response must be concise. 1. What is the ratio of the Debt(current US$) of Syrian Arab Republic in 1989 to that in 1991?
Ensure brevity in your answer.  6.06. What is the ratio of the Debt(current US$) in Maldives in 1989 to that in 1992?
Offer a terse response. 1.47. What is the ratio of the Debt(current US$) of Myanmar in 1989 to that in 1992?
Provide a succinct answer. 0.04. What is the ratio of the Debt(current US$) in Solomon Islands in 1989 to that in 1992?
Offer a terse response. 4.79. What is the ratio of the Debt(current US$) of Syrian Arab Republic in 1989 to that in 1992?
Give a very brief answer. 7.21. What is the ratio of the Debt(current US$) in Maldives in 1990 to that in 1991?
Provide a succinct answer. 0.26. What is the ratio of the Debt(current US$) of Solomon Islands in 1990 to that in 1991?
Give a very brief answer. 1. What is the ratio of the Debt(current US$) of Syrian Arab Republic in 1990 to that in 1991?
Provide a short and direct response. 3.32. What is the ratio of the Debt(current US$) in Maldives in 1990 to that in 1992?
Offer a terse response. 0.53. What is the ratio of the Debt(current US$) of Myanmar in 1990 to that in 1992?
Give a very brief answer. 0.37. What is the ratio of the Debt(current US$) in Solomon Islands in 1990 to that in 1992?
Give a very brief answer. 4.79. What is the ratio of the Debt(current US$) of Syrian Arab Republic in 1990 to that in 1992?
Keep it short and to the point. 3.94. What is the ratio of the Debt(current US$) in Maldives in 1991 to that in 1992?
Your answer should be very brief. 2.05. What is the ratio of the Debt(current US$) of Myanmar in 1991 to that in 1992?
Your answer should be very brief. 0.37. What is the ratio of the Debt(current US$) in Solomon Islands in 1991 to that in 1992?
Offer a terse response. 4.79. What is the ratio of the Debt(current US$) of Syrian Arab Republic in 1991 to that in 1992?
Your response must be concise. 1.19. What is the difference between the highest and the second highest Debt(current US$) in Maldives?
Ensure brevity in your answer.  1.86e+06. What is the difference between the highest and the second highest Debt(current US$) of Myanmar?
Offer a terse response. 1.07e+07. What is the difference between the highest and the second highest Debt(current US$) of Solomon Islands?
Your answer should be compact. 6.74e+06. What is the difference between the highest and the second highest Debt(current US$) in Syrian Arab Republic?
Provide a short and direct response. 1.41e+07. What is the difference between the highest and the lowest Debt(current US$) in Maldives?
Your response must be concise. 5.12e+06. What is the difference between the highest and the lowest Debt(current US$) in Myanmar?
Make the answer very short. 6.30e+07. What is the difference between the highest and the lowest Debt(current US$) of Solomon Islands?
Make the answer very short. 1.86e+07. What is the difference between the highest and the lowest Debt(current US$) in Syrian Arab Republic?
Keep it short and to the point. 1.99e+08. 